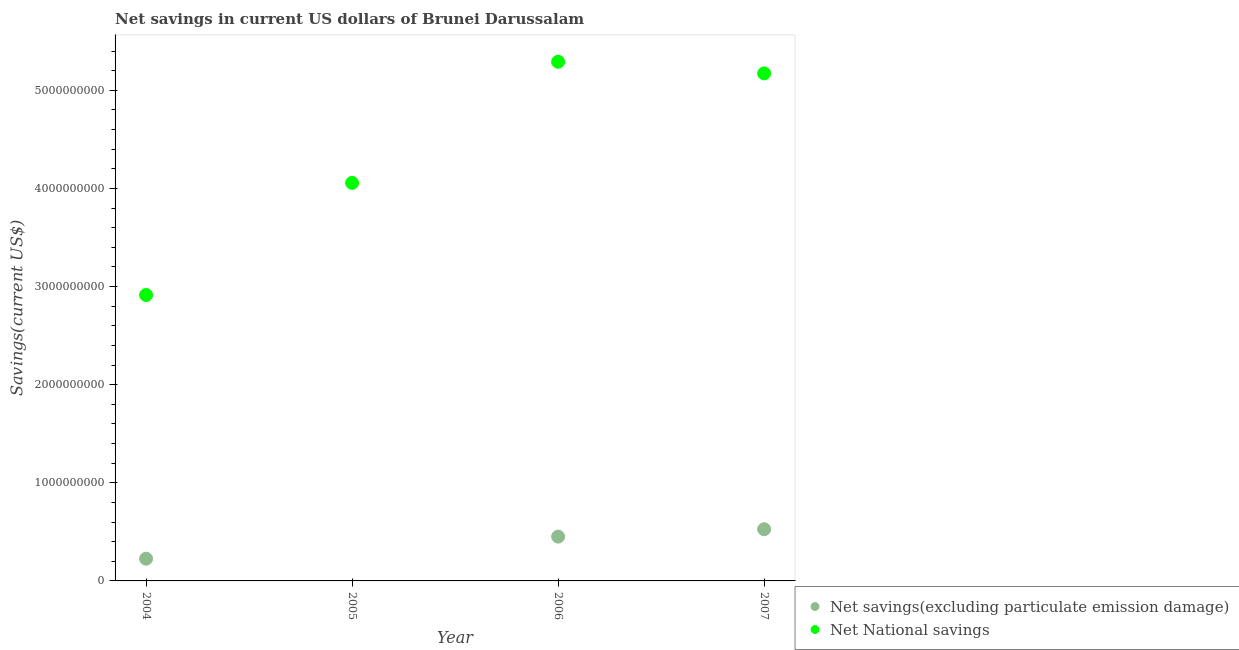What is the net savings(excluding particulate emission damage) in 2006?
Give a very brief answer. 4.51e+08. Across all years, what is the maximum net savings(excluding particulate emission damage)?
Your response must be concise. 5.27e+08. Across all years, what is the minimum net national savings?
Offer a terse response. 2.91e+09. In which year was the net savings(excluding particulate emission damage) maximum?
Offer a terse response. 2007. What is the total net savings(excluding particulate emission damage) in the graph?
Make the answer very short. 1.20e+09. What is the difference between the net savings(excluding particulate emission damage) in 2006 and that in 2007?
Your answer should be very brief. -7.55e+07. What is the difference between the net savings(excluding particulate emission damage) in 2007 and the net national savings in 2004?
Ensure brevity in your answer.  -2.39e+09. What is the average net savings(excluding particulate emission damage) per year?
Ensure brevity in your answer.  3.01e+08. In the year 2006, what is the difference between the net national savings and net savings(excluding particulate emission damage)?
Provide a succinct answer. 4.84e+09. In how many years, is the net savings(excluding particulate emission damage) greater than 3400000000 US$?
Offer a terse response. 0. What is the ratio of the net national savings in 2005 to that in 2007?
Ensure brevity in your answer.  0.78. Is the net savings(excluding particulate emission damage) in 2004 less than that in 2007?
Offer a terse response. Yes. What is the difference between the highest and the second highest net savings(excluding particulate emission damage)?
Give a very brief answer. 7.55e+07. What is the difference between the highest and the lowest net national savings?
Your answer should be compact. 2.38e+09. In how many years, is the net savings(excluding particulate emission damage) greater than the average net savings(excluding particulate emission damage) taken over all years?
Offer a terse response. 2. Is the sum of the net savings(excluding particulate emission damage) in 2006 and 2007 greater than the maximum net national savings across all years?
Provide a short and direct response. No. Does the net savings(excluding particulate emission damage) monotonically increase over the years?
Offer a terse response. No. Are the values on the major ticks of Y-axis written in scientific E-notation?
Ensure brevity in your answer.  No. Does the graph contain any zero values?
Offer a terse response. Yes. Where does the legend appear in the graph?
Your answer should be very brief. Bottom right. How many legend labels are there?
Your answer should be compact. 2. What is the title of the graph?
Ensure brevity in your answer.  Net savings in current US dollars of Brunei Darussalam. Does "Measles" appear as one of the legend labels in the graph?
Make the answer very short. No. What is the label or title of the X-axis?
Provide a short and direct response. Year. What is the label or title of the Y-axis?
Make the answer very short. Savings(current US$). What is the Savings(current US$) in Net savings(excluding particulate emission damage) in 2004?
Make the answer very short. 2.27e+08. What is the Savings(current US$) of Net National savings in 2004?
Your response must be concise. 2.91e+09. What is the Savings(current US$) in Net savings(excluding particulate emission damage) in 2005?
Offer a terse response. 0. What is the Savings(current US$) of Net National savings in 2005?
Your answer should be compact. 4.06e+09. What is the Savings(current US$) in Net savings(excluding particulate emission damage) in 2006?
Offer a very short reply. 4.51e+08. What is the Savings(current US$) of Net National savings in 2006?
Keep it short and to the point. 5.29e+09. What is the Savings(current US$) in Net savings(excluding particulate emission damage) in 2007?
Keep it short and to the point. 5.27e+08. What is the Savings(current US$) of Net National savings in 2007?
Make the answer very short. 5.17e+09. Across all years, what is the maximum Savings(current US$) in Net savings(excluding particulate emission damage)?
Your response must be concise. 5.27e+08. Across all years, what is the maximum Savings(current US$) of Net National savings?
Provide a succinct answer. 5.29e+09. Across all years, what is the minimum Savings(current US$) in Net savings(excluding particulate emission damage)?
Your answer should be compact. 0. Across all years, what is the minimum Savings(current US$) of Net National savings?
Offer a very short reply. 2.91e+09. What is the total Savings(current US$) in Net savings(excluding particulate emission damage) in the graph?
Your answer should be compact. 1.20e+09. What is the total Savings(current US$) in Net National savings in the graph?
Give a very brief answer. 1.74e+1. What is the difference between the Savings(current US$) in Net National savings in 2004 and that in 2005?
Ensure brevity in your answer.  -1.14e+09. What is the difference between the Savings(current US$) in Net savings(excluding particulate emission damage) in 2004 and that in 2006?
Your answer should be very brief. -2.25e+08. What is the difference between the Savings(current US$) in Net National savings in 2004 and that in 2006?
Keep it short and to the point. -2.38e+09. What is the difference between the Savings(current US$) in Net savings(excluding particulate emission damage) in 2004 and that in 2007?
Offer a very short reply. -3.00e+08. What is the difference between the Savings(current US$) in Net National savings in 2004 and that in 2007?
Give a very brief answer. -2.26e+09. What is the difference between the Savings(current US$) of Net National savings in 2005 and that in 2006?
Make the answer very short. -1.23e+09. What is the difference between the Savings(current US$) in Net National savings in 2005 and that in 2007?
Offer a very short reply. -1.12e+09. What is the difference between the Savings(current US$) in Net savings(excluding particulate emission damage) in 2006 and that in 2007?
Offer a terse response. -7.55e+07. What is the difference between the Savings(current US$) of Net National savings in 2006 and that in 2007?
Give a very brief answer. 1.18e+08. What is the difference between the Savings(current US$) of Net savings(excluding particulate emission damage) in 2004 and the Savings(current US$) of Net National savings in 2005?
Keep it short and to the point. -3.83e+09. What is the difference between the Savings(current US$) in Net savings(excluding particulate emission damage) in 2004 and the Savings(current US$) in Net National savings in 2006?
Offer a terse response. -5.06e+09. What is the difference between the Savings(current US$) in Net savings(excluding particulate emission damage) in 2004 and the Savings(current US$) in Net National savings in 2007?
Keep it short and to the point. -4.95e+09. What is the difference between the Savings(current US$) in Net savings(excluding particulate emission damage) in 2006 and the Savings(current US$) in Net National savings in 2007?
Give a very brief answer. -4.72e+09. What is the average Savings(current US$) of Net savings(excluding particulate emission damage) per year?
Ensure brevity in your answer.  3.01e+08. What is the average Savings(current US$) of Net National savings per year?
Make the answer very short. 4.36e+09. In the year 2004, what is the difference between the Savings(current US$) in Net savings(excluding particulate emission damage) and Savings(current US$) in Net National savings?
Provide a succinct answer. -2.69e+09. In the year 2006, what is the difference between the Savings(current US$) of Net savings(excluding particulate emission damage) and Savings(current US$) of Net National savings?
Your response must be concise. -4.84e+09. In the year 2007, what is the difference between the Savings(current US$) in Net savings(excluding particulate emission damage) and Savings(current US$) in Net National savings?
Provide a succinct answer. -4.65e+09. What is the ratio of the Savings(current US$) of Net National savings in 2004 to that in 2005?
Your answer should be compact. 0.72. What is the ratio of the Savings(current US$) in Net savings(excluding particulate emission damage) in 2004 to that in 2006?
Give a very brief answer. 0.5. What is the ratio of the Savings(current US$) of Net National savings in 2004 to that in 2006?
Keep it short and to the point. 0.55. What is the ratio of the Savings(current US$) of Net savings(excluding particulate emission damage) in 2004 to that in 2007?
Make the answer very short. 0.43. What is the ratio of the Savings(current US$) in Net National savings in 2004 to that in 2007?
Provide a short and direct response. 0.56. What is the ratio of the Savings(current US$) of Net National savings in 2005 to that in 2006?
Give a very brief answer. 0.77. What is the ratio of the Savings(current US$) in Net National savings in 2005 to that in 2007?
Your response must be concise. 0.78. What is the ratio of the Savings(current US$) in Net savings(excluding particulate emission damage) in 2006 to that in 2007?
Offer a very short reply. 0.86. What is the ratio of the Savings(current US$) in Net National savings in 2006 to that in 2007?
Ensure brevity in your answer.  1.02. What is the difference between the highest and the second highest Savings(current US$) in Net savings(excluding particulate emission damage)?
Your response must be concise. 7.55e+07. What is the difference between the highest and the second highest Savings(current US$) of Net National savings?
Make the answer very short. 1.18e+08. What is the difference between the highest and the lowest Savings(current US$) in Net savings(excluding particulate emission damage)?
Offer a very short reply. 5.27e+08. What is the difference between the highest and the lowest Savings(current US$) in Net National savings?
Offer a terse response. 2.38e+09. 